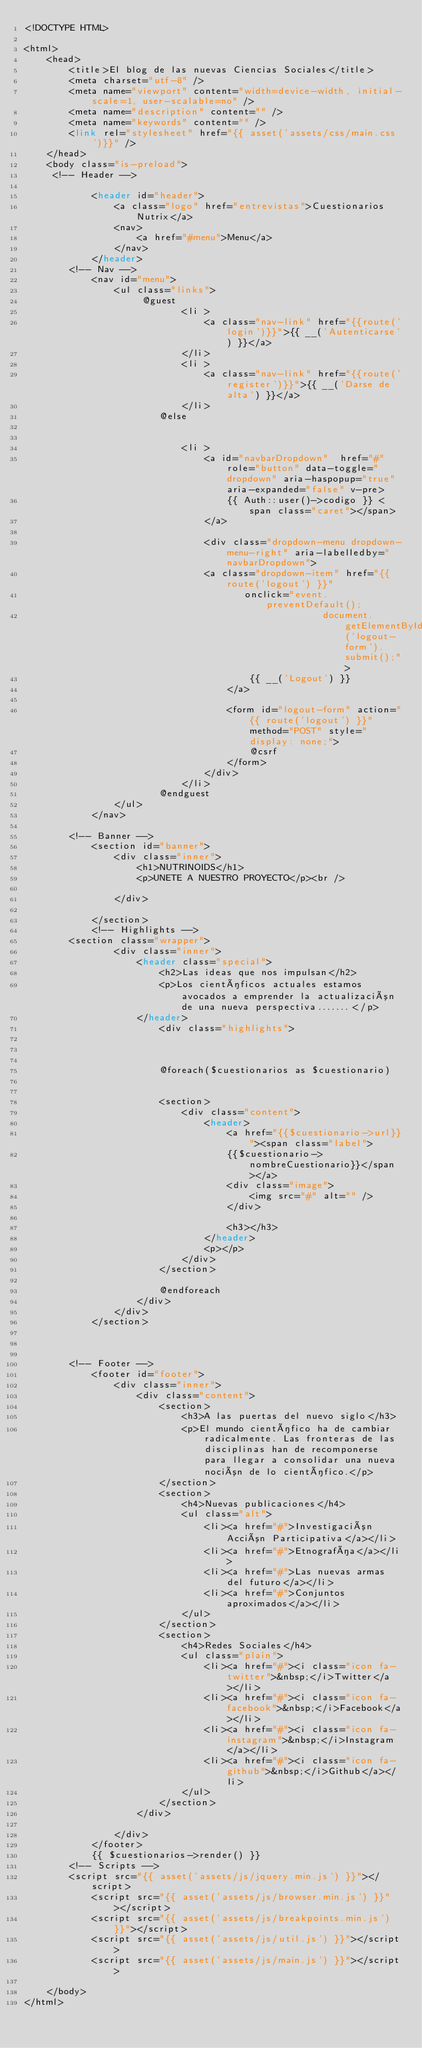Convert code to text. <code><loc_0><loc_0><loc_500><loc_500><_PHP_><!DOCTYPE HTML>

<html>
	<head>
		<title>El blog de las nuevas Ciencias Sociales</title>
		<meta charset="utf-8" />
		<meta name="viewport" content="width=device-width, initial-scale=1, user-scalable=no" />
		<meta name="description" content="" />
		<meta name="keywords" content="" />
		<link rel="stylesheet" href="{{ asset('assets/css/main.css')}}" />
	</head>
	<body class="is-preload">
	 <!-- Header -->
	
            <header id="header">
				<a class="logo" href="entrevistas">Cuestionarios Nutrix</a>
				<nav>
					<a href="#menu">Menu</a>
				</nav>
			</header>
		<!-- Nav -->
			<nav id="menu">
				<ul class="links">
				     @guest
                            <li >
                                <a class="nav-link" href="{{route('login')}}">{{ __('Autenticarse') }}</a>
                            </li>
                            <li >
                                <a class="nav-link" href="{{route('register')}}">{{ __('Darse de  alta') }}</a>
                            </li>
                        @else
                        	
                            
                            <li >
                                <a id="navbarDropdown"  href="#" role="button" data-toggle="dropdown" aria-haspopup="true" aria-expanded="false" v-pre>
                                    {{ Auth::user()->codigo }} <span class="caret"></span>
                                </a>

                                <div class="dropdown-menu dropdown-menu-right" aria-labelledby="navbarDropdown">
								<a class="dropdown-item" href="{{ route('logout') }}"
                                       onclick="event.preventDefault();
                                                     document.getElementById('logout-form').submit();">
                                        {{ __('Logout') }}
                                    </a>

                                    <form id="logout-form" action="{{ route('logout') }}" method="POST" style="display: none;">
                                        @csrf
                                    </form>
                                </div>
                            </li>
                        @endguest
				</ul>
			</nav>

		<!-- Banner -->
			<section id="banner">
				<div class="inner">
					<h1>NUTRINOIDS</h1>
					<p>UNETE A NUESTRO PROYECTO</p><br />
					
				</div>
				
			</section>
			<!-- Highlights -->
		<section class="wrapper">
				<div class="inner">
					<header class="special">
						<h2>Las ideas que nos impulsan</h2>
						<p>Los científicos actuales estamos avocados a emprender la actualización de una nueva perspectiva.......</p>
					</header>
						<div class="highlights">

					

						@foreach($cuestionarios as $cuestionario)


						<section>
							<div class="content">
								<header>
									<a href="{{$cuestionario->url}}"><span class="label">
									{{$cuestionario->nombreCuestionario}}</span></a>
									<div class="image">
										<img src="#" alt="" />
									</div>
								
									<h3></h3>
								</header>
								<p></p>
							</div>
                        </section>
                       
						@endforeach
					</div>
				</div>
			</section>
			
		

		<!-- Footer -->
			<footer id="footer">
				<div class="inner">
					<div class="content">
						<section>
							<h3>A las puertas del nuevo siglo</h3>
							<p>El mundo científico ha de cambiar radicalmente. Las fronteras de las disciplinas han de recomponerse para llegar a consolidar una nueva noción de lo científico.</p>
						</section>
						<section>
							<h4>Nuevas publicaciones</h4>
							<ul class="alt">
								<li><a href="#">Investigación Acción Participativa</a></li>
								<li><a href="#">Etnografía</a></li>
								<li><a href="#">Las nuevas armas del futuro</a></li>
								<li><a href="#">Conjuntos aproximados</a></li>
							</ul>
						</section>
						<section>
							<h4>Redes Sociales</h4>
							<ul class="plain">
								<li><a href="#"><i class="icon fa-twitter">&nbsp;</i>Twitter</a></li>
								<li><a href="#"><i class="icon fa-facebook">&nbsp;</i>Facebook</a></li>
								<li><a href="#"><i class="icon fa-instagram">&nbsp;</i>Instagram</a></li>
								<li><a href="#"><i class="icon fa-github">&nbsp;</i>Github</a></li>
							</ul>
						</section>
					</div>
					
				</div>
			</footer>
			{{ $cuestionarios->render() }}
		<!-- Scripts -->
		<script src="{{ asset('assets/js/jquery.min.js') }}"></script>
			<script src="{{ asset('assets/js/browser.min.js') }}"></script>
			<script src="{{ asset('assets/js/breakpoints.min.js') }}"></script>
			<script src="{{ asset('assets/js/util.js') }}"></script>
			<script src="{{ asset('assets/js/main.js') }}"></script>

	</body>
</html></code> 